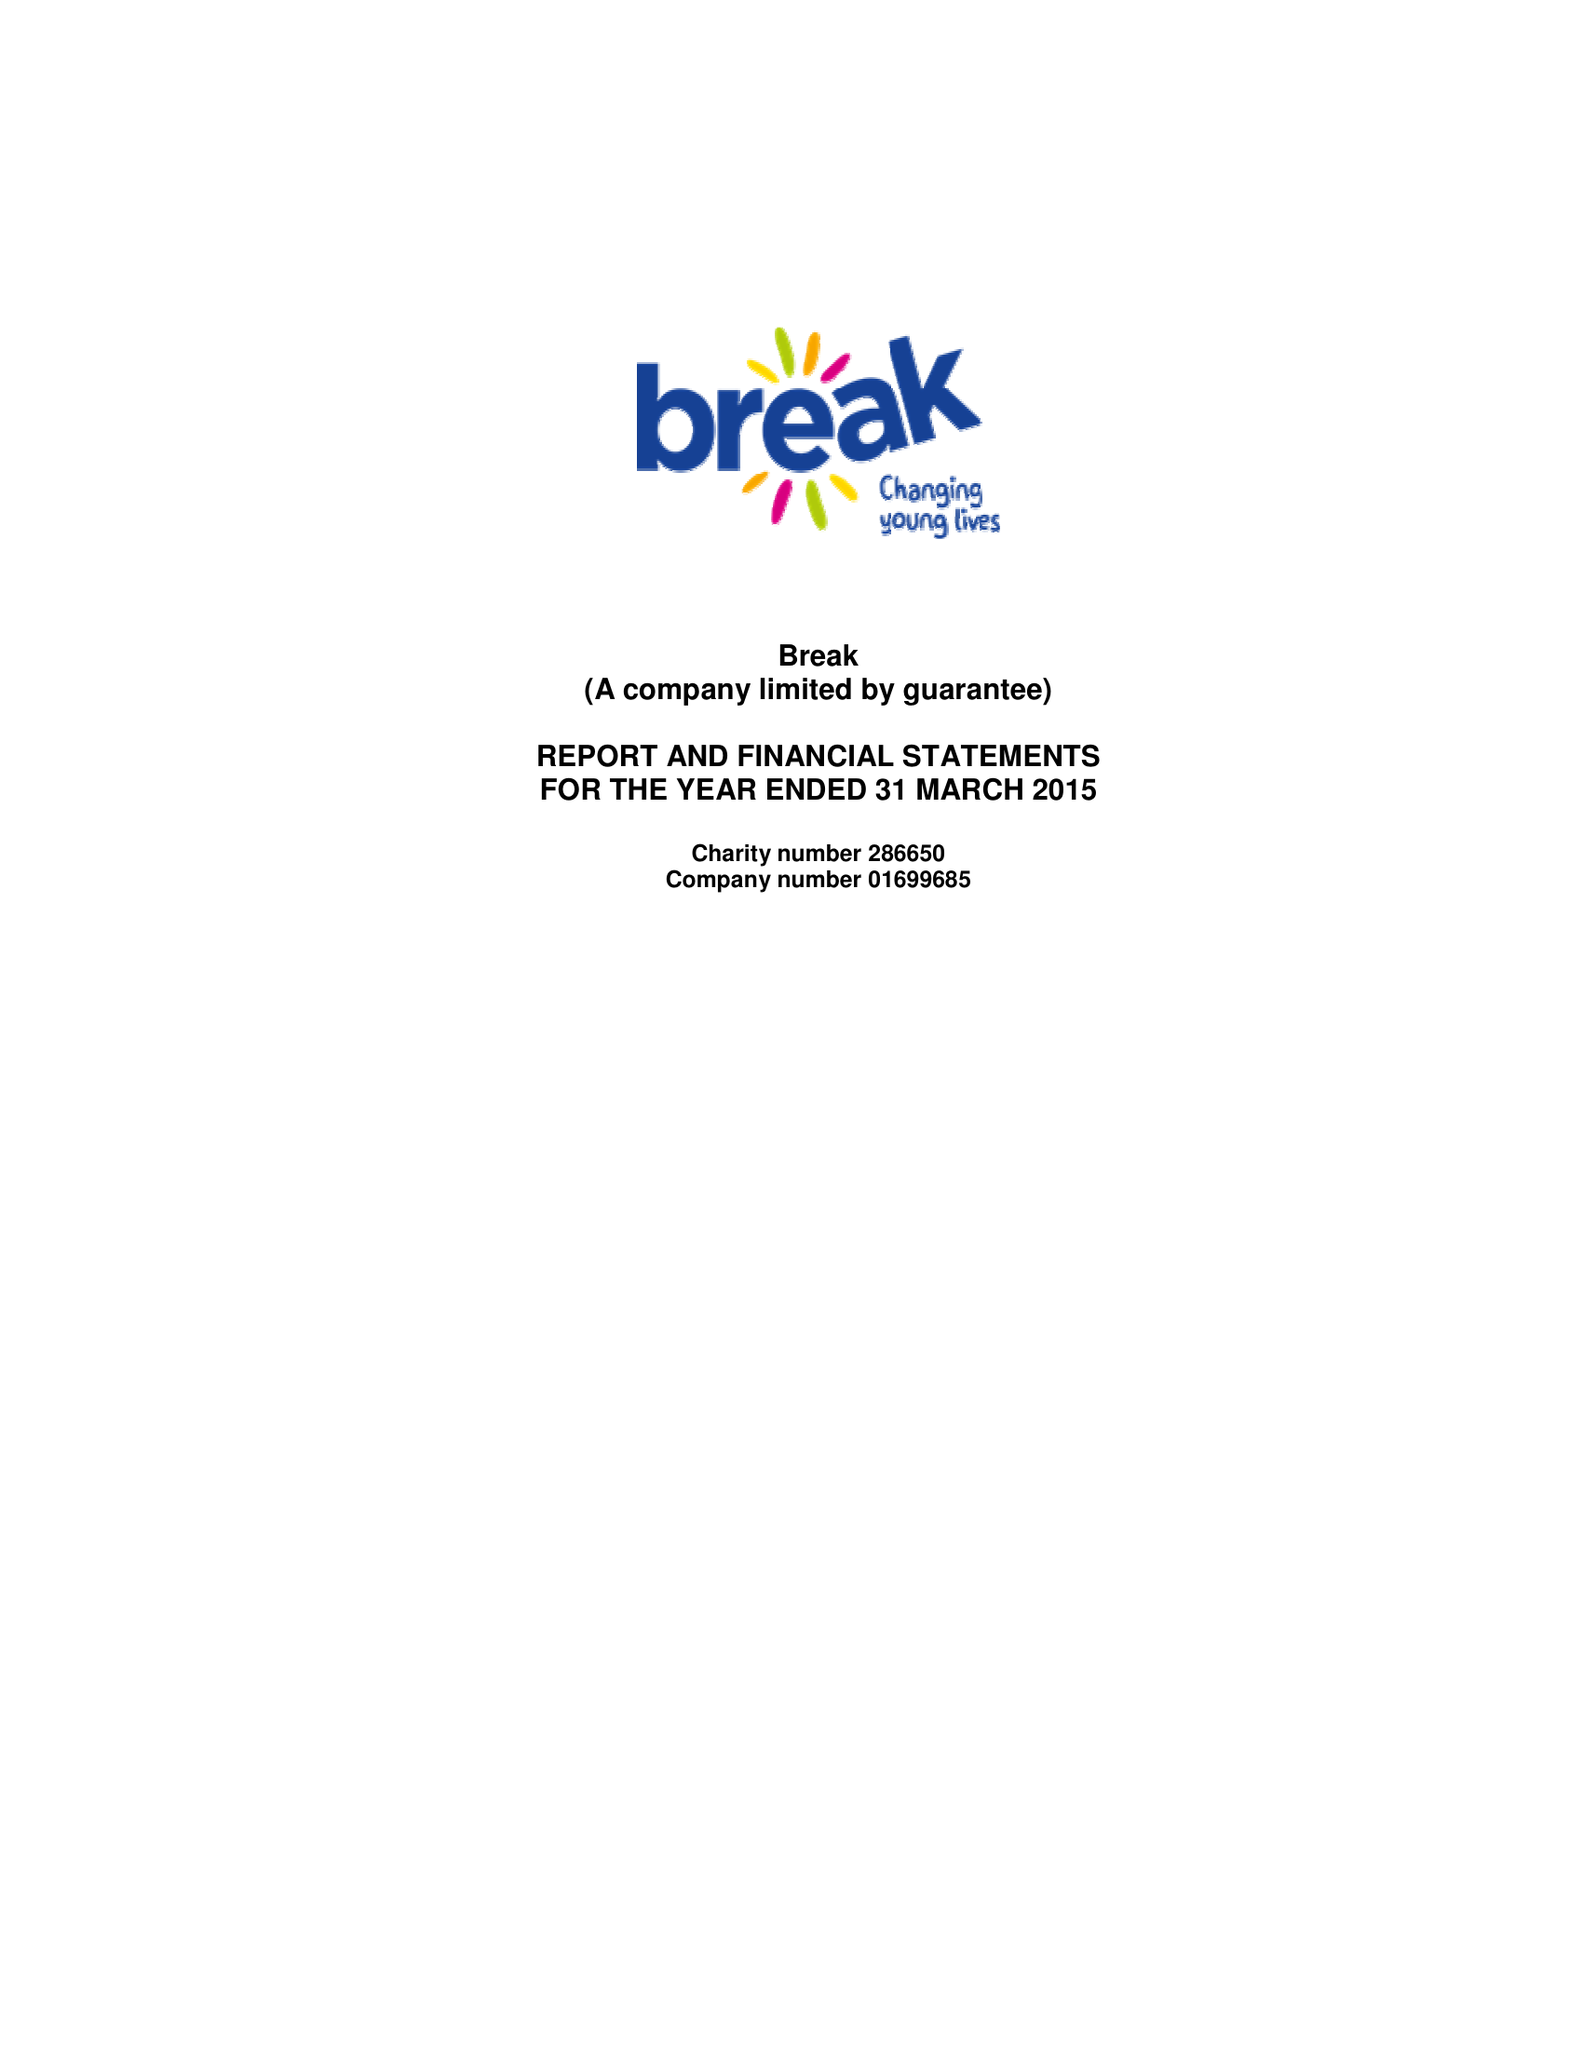What is the value for the charity_number?
Answer the question using a single word or phrase. 286650 